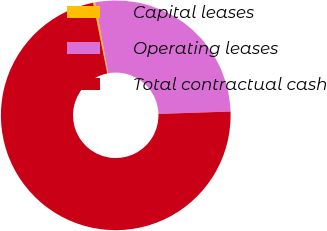<chart> <loc_0><loc_0><loc_500><loc_500><pie_chart><fcel>Capital leases<fcel>Operating leases<fcel>Total contractual cash<nl><fcel>0.3%<fcel>27.34%<fcel>72.36%<nl></chart> 